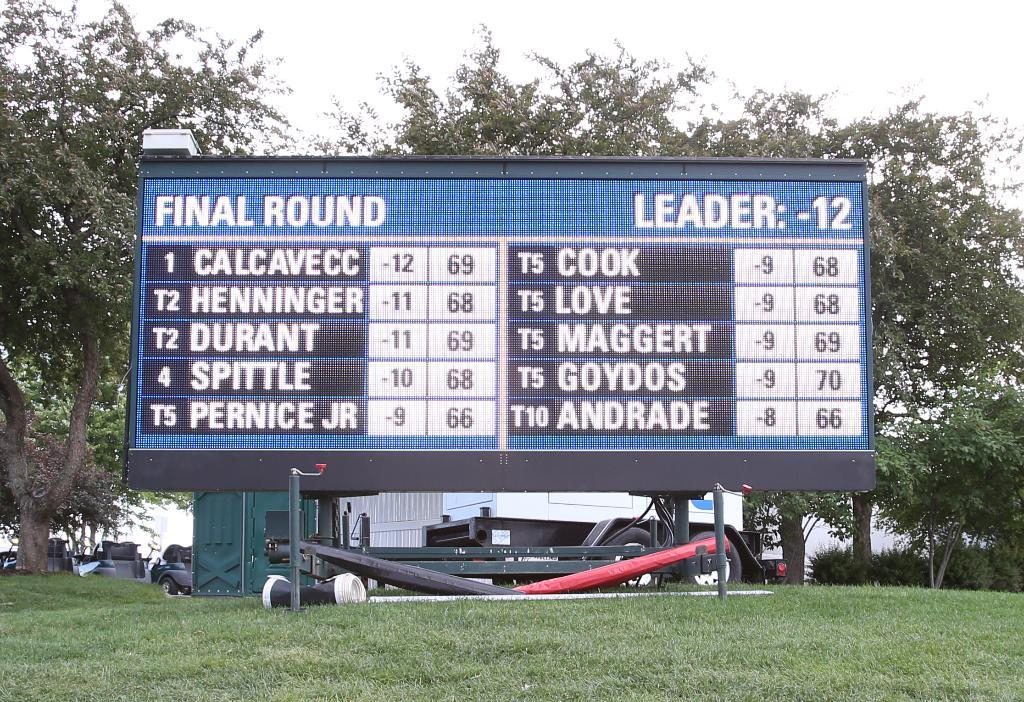<image>
Provide a brief description of the given image. A large blue black and white score board with calcavecc in first place in the final round. 